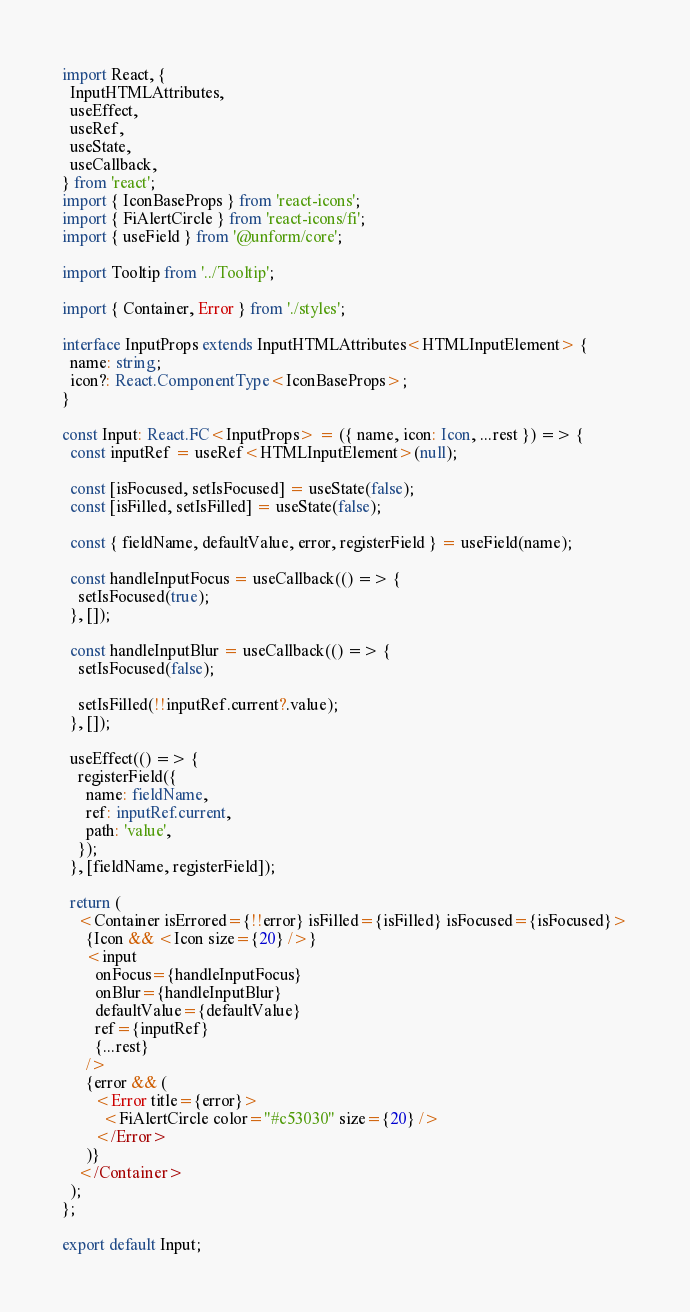Convert code to text. <code><loc_0><loc_0><loc_500><loc_500><_TypeScript_>import React, {
  InputHTMLAttributes,
  useEffect,
  useRef,
  useState,
  useCallback,
} from 'react';
import { IconBaseProps } from 'react-icons';
import { FiAlertCircle } from 'react-icons/fi';
import { useField } from '@unform/core';

import Tooltip from '../Tooltip';

import { Container, Error } from './styles';

interface InputProps extends InputHTMLAttributes<HTMLInputElement> {
  name: string;
  icon?: React.ComponentType<IconBaseProps>;
}

const Input: React.FC<InputProps> = ({ name, icon: Icon, ...rest }) => {
  const inputRef = useRef<HTMLInputElement>(null);

  const [isFocused, setIsFocused] = useState(false);
  const [isFilled, setIsFilled] = useState(false);

  const { fieldName, defaultValue, error, registerField } = useField(name);

  const handleInputFocus = useCallback(() => {
    setIsFocused(true);
  }, []);

  const handleInputBlur = useCallback(() => {
    setIsFocused(false);

    setIsFilled(!!inputRef.current?.value);
  }, []);

  useEffect(() => {
    registerField({
      name: fieldName,
      ref: inputRef.current,
      path: 'value',
    });
  }, [fieldName, registerField]);

  return (
    <Container isErrored={!!error} isFilled={isFilled} isFocused={isFocused}>
      {Icon && <Icon size={20} />}
      <input
        onFocus={handleInputFocus}
        onBlur={handleInputBlur}
        defaultValue={defaultValue}
        ref={inputRef}
        {...rest}
      />
      {error && (
        <Error title={error}>
          <FiAlertCircle color="#c53030" size={20} />
        </Error>
      )}
    </Container>
  );
};

export default Input;
</code> 